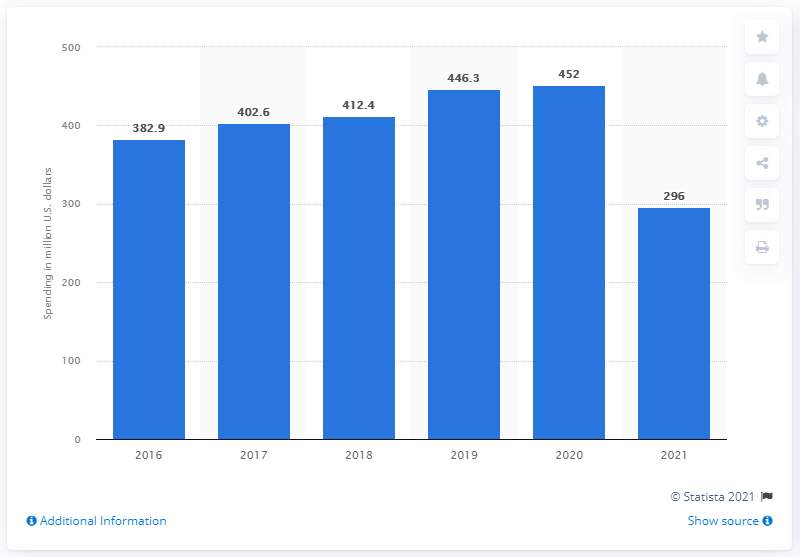Highlight a few significant elements in this photo. In the year 2021, TJX invested approximately 296 million U.S. dollars in advertising worldwide. TJX invested approximately $296 million in advertising in 2021. 